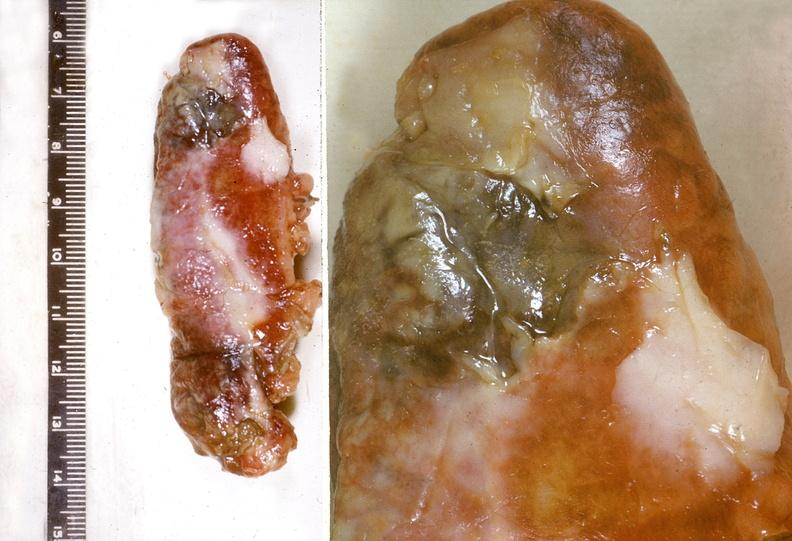does outside adrenal capsule section show appendix, acute appendicitis with gangreene?
Answer the question using a single word or phrase. No 